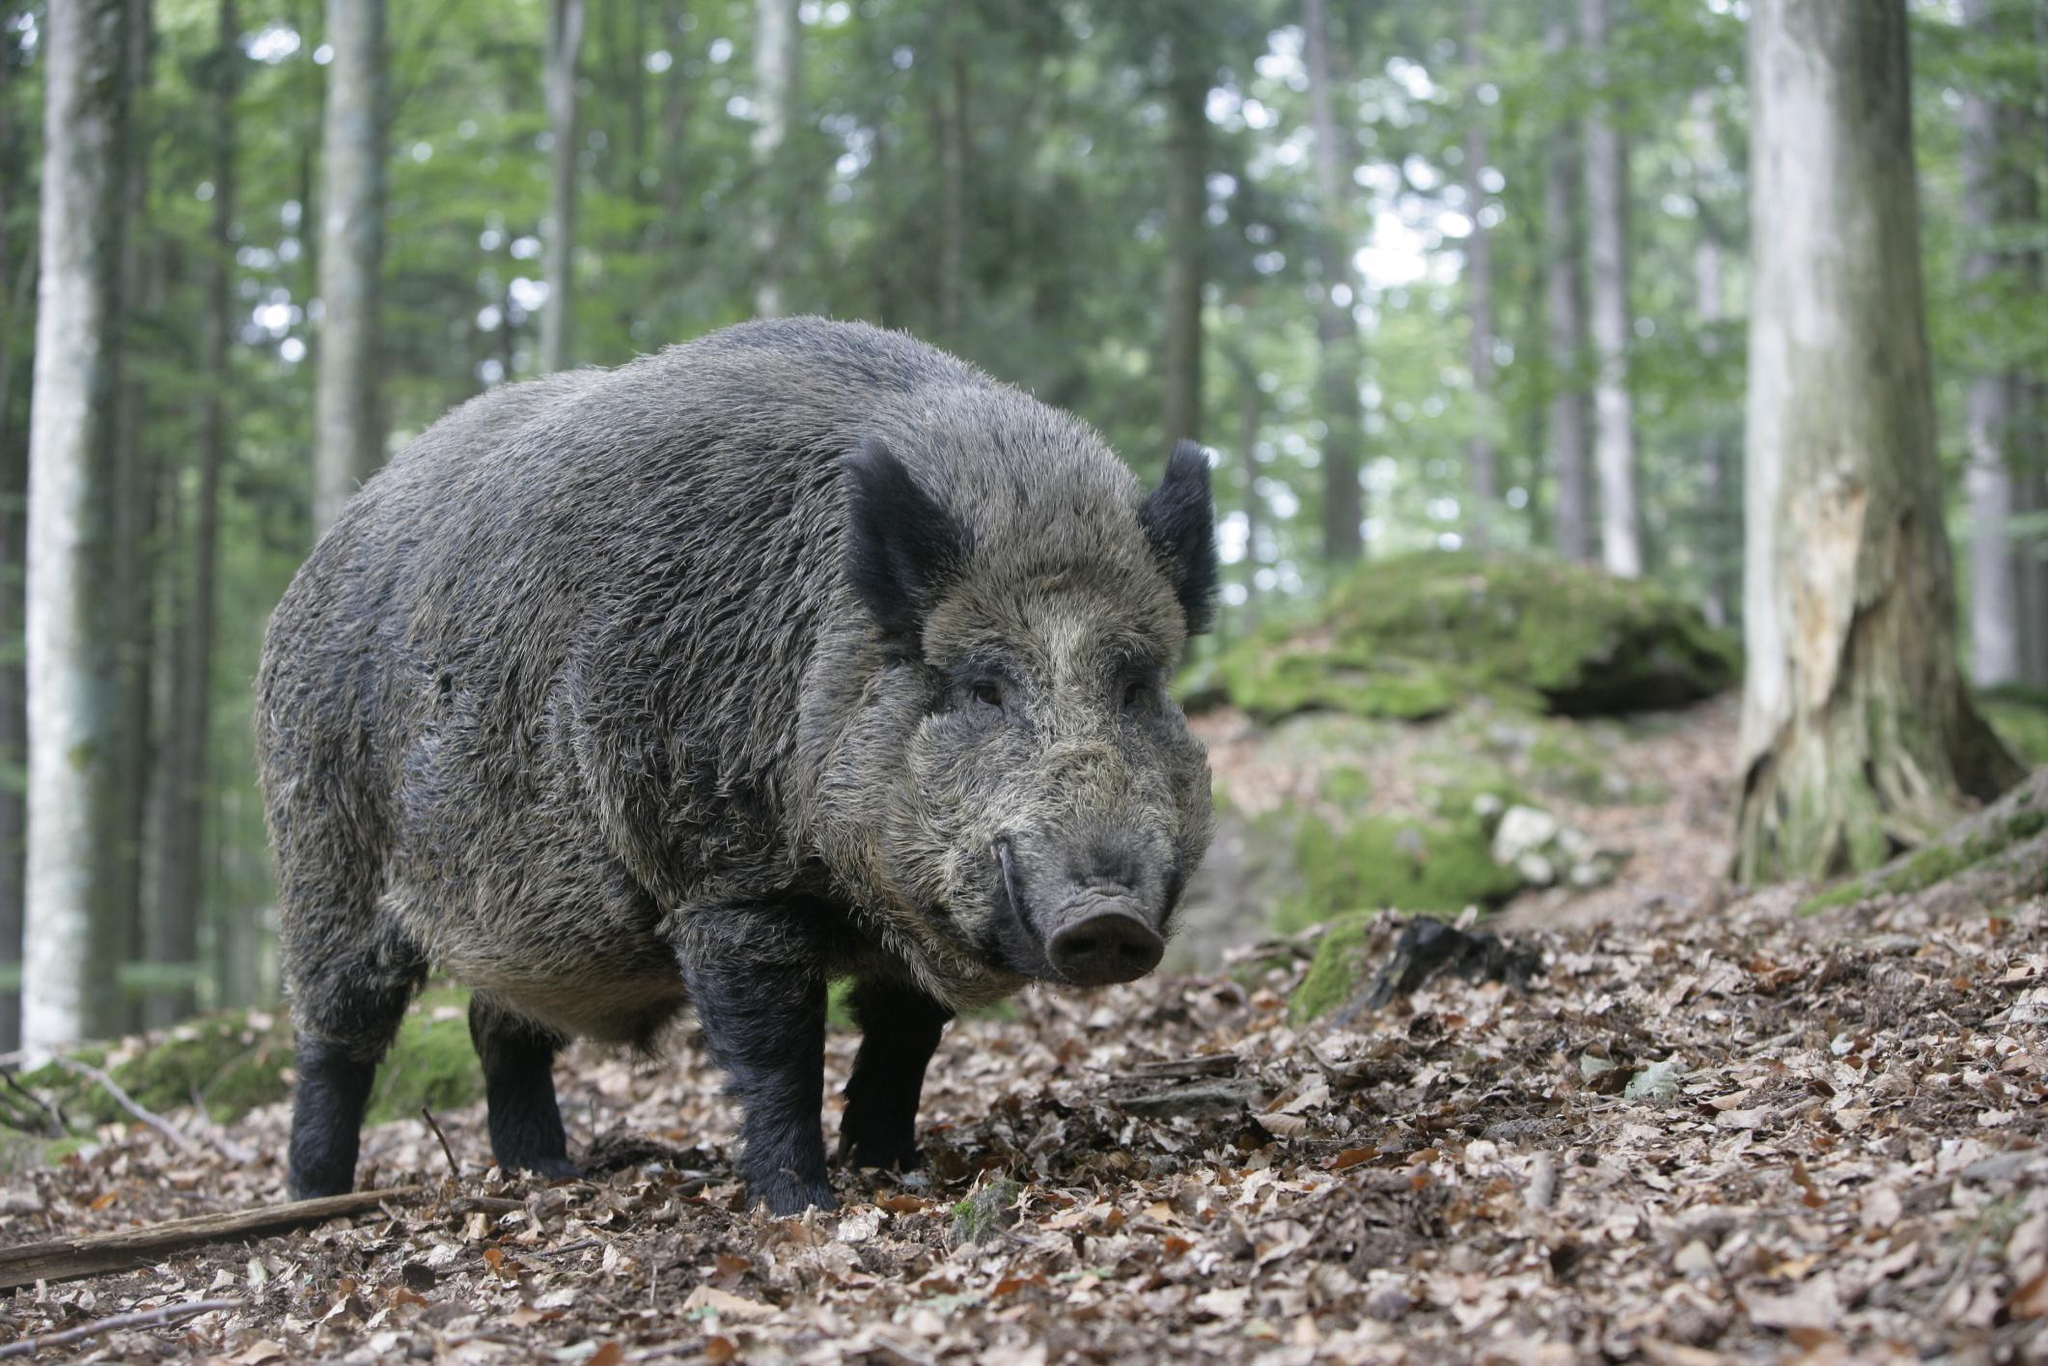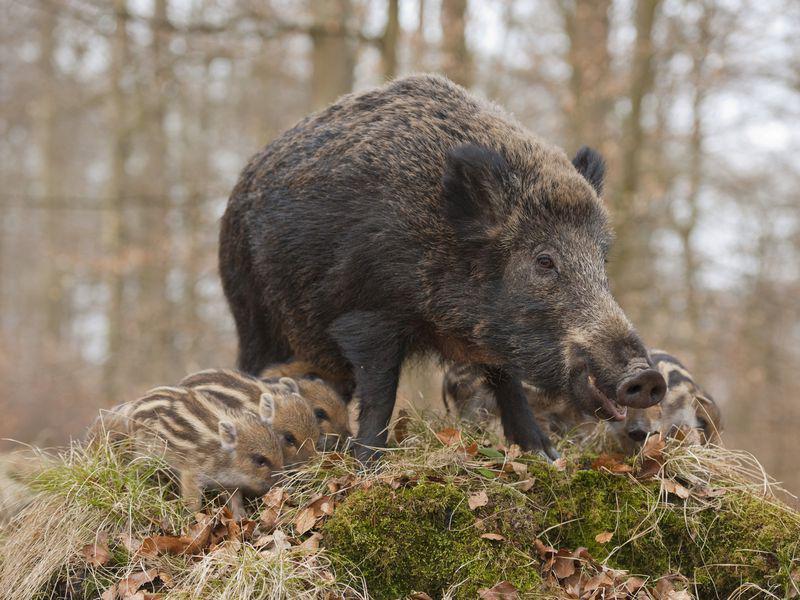The first image is the image on the left, the second image is the image on the right. Considering the images on both sides, is "The left image contains at least three times as many wild pigs as the right image." valid? Answer yes or no. No. The first image is the image on the left, the second image is the image on the right. For the images displayed, is the sentence "The image on the left shows a single warthog." factually correct? Answer yes or no. Yes. 